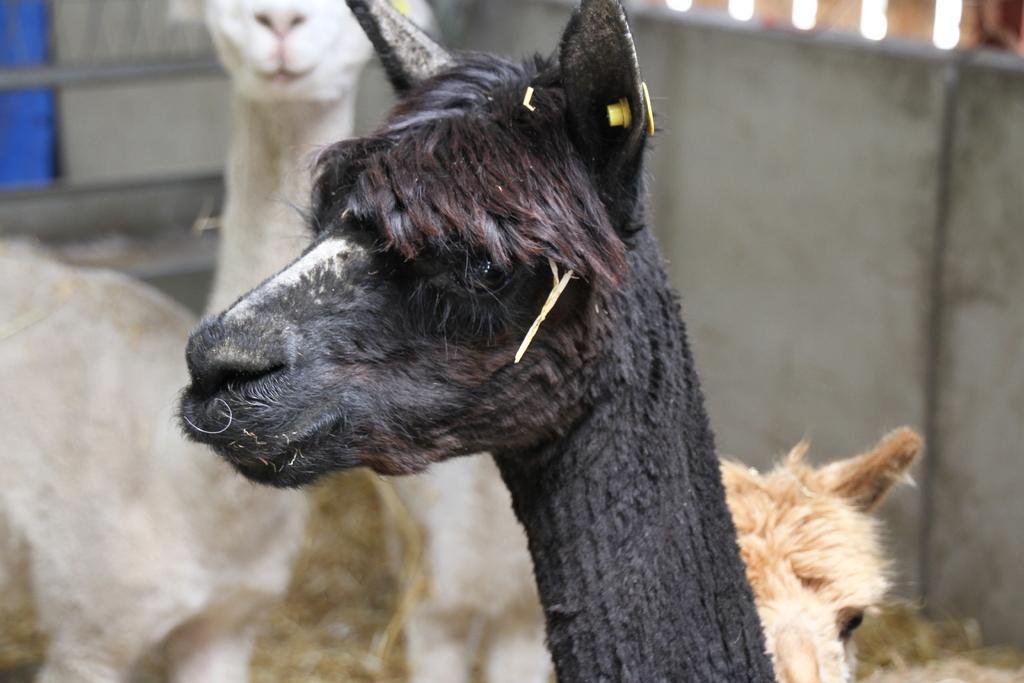How would you summarize this image in a sentence or two? In this image I can see an animal which is black in color. In the background I can see few other animals which are white and brown in color and the wall. 